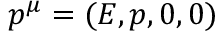Convert formula to latex. <formula><loc_0><loc_0><loc_500><loc_500>p ^ { \mu } = ( E , p , 0 , 0 )</formula> 